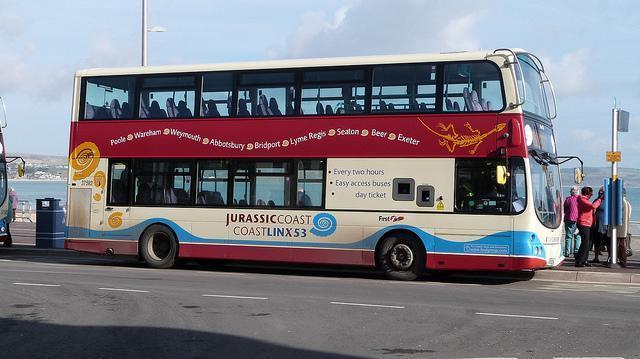How many of the bears legs are bent?
Give a very brief answer. 0. 